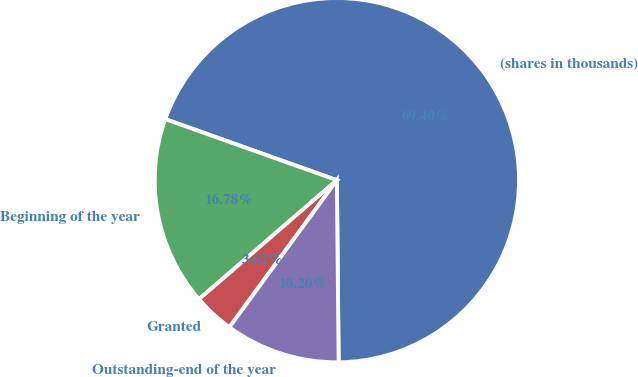Convert chart to OTSL. <chart><loc_0><loc_0><loc_500><loc_500><pie_chart><fcel>(shares in thousands)<fcel>Beginning of the year<fcel>Granted<fcel>Outstanding-end of the year<nl><fcel>69.41%<fcel>16.78%<fcel>3.62%<fcel>10.2%<nl></chart> 